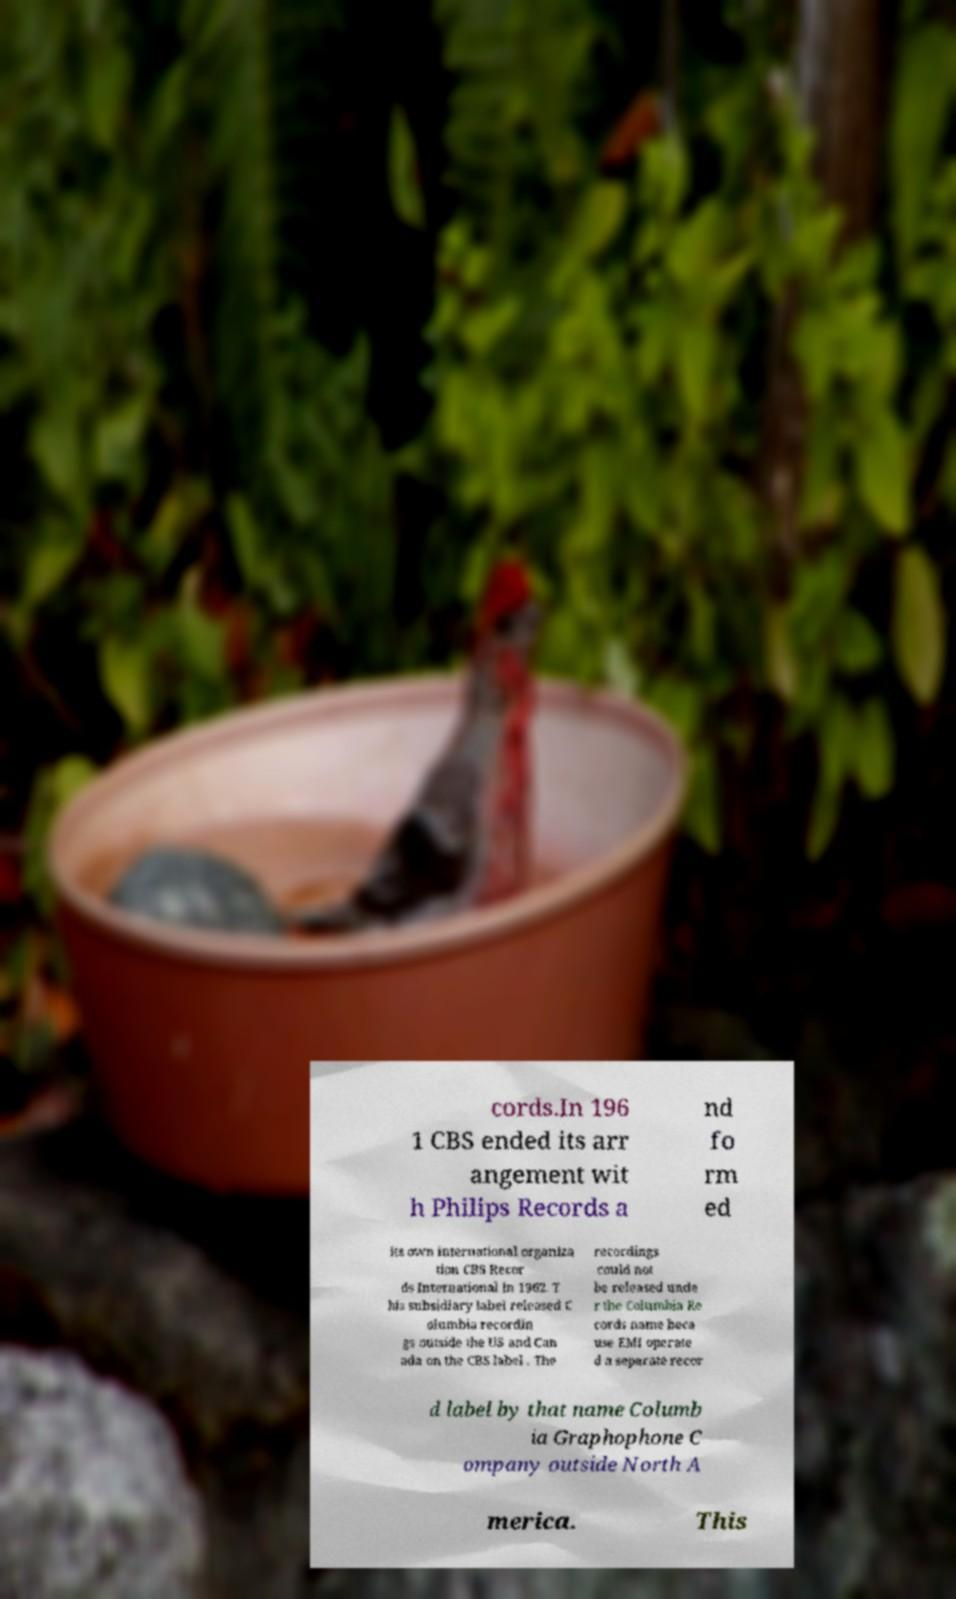Can you accurately transcribe the text from the provided image for me? cords.In 196 1 CBS ended its arr angement wit h Philips Records a nd fo rm ed its own international organiza tion CBS Recor ds International in 1962. T his subsidiary label released C olumbia recordin gs outside the US and Can ada on the CBS label . The recordings could not be released unde r the Columbia Re cords name beca use EMI operate d a separate recor d label by that name Columb ia Graphophone C ompany outside North A merica. This 